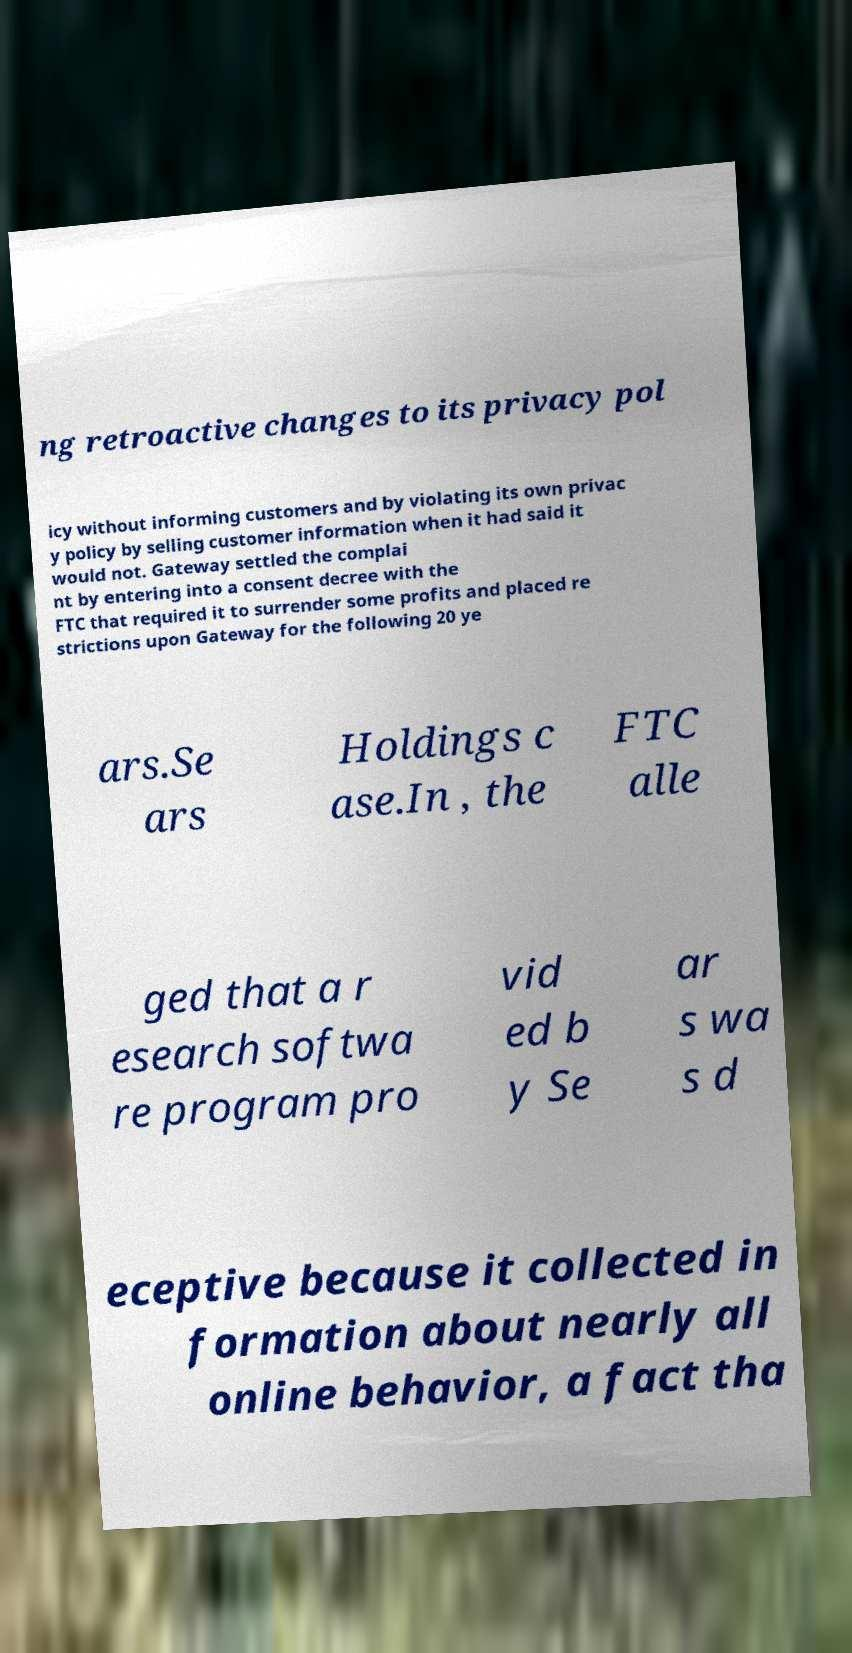There's text embedded in this image that I need extracted. Can you transcribe it verbatim? ng retroactive changes to its privacy pol icy without informing customers and by violating its own privac y policy by selling customer information when it had said it would not. Gateway settled the complai nt by entering into a consent decree with the FTC that required it to surrender some profits and placed re strictions upon Gateway for the following 20 ye ars.Se ars Holdings c ase.In , the FTC alle ged that a r esearch softwa re program pro vid ed b y Se ar s wa s d eceptive because it collected in formation about nearly all online behavior, a fact tha 